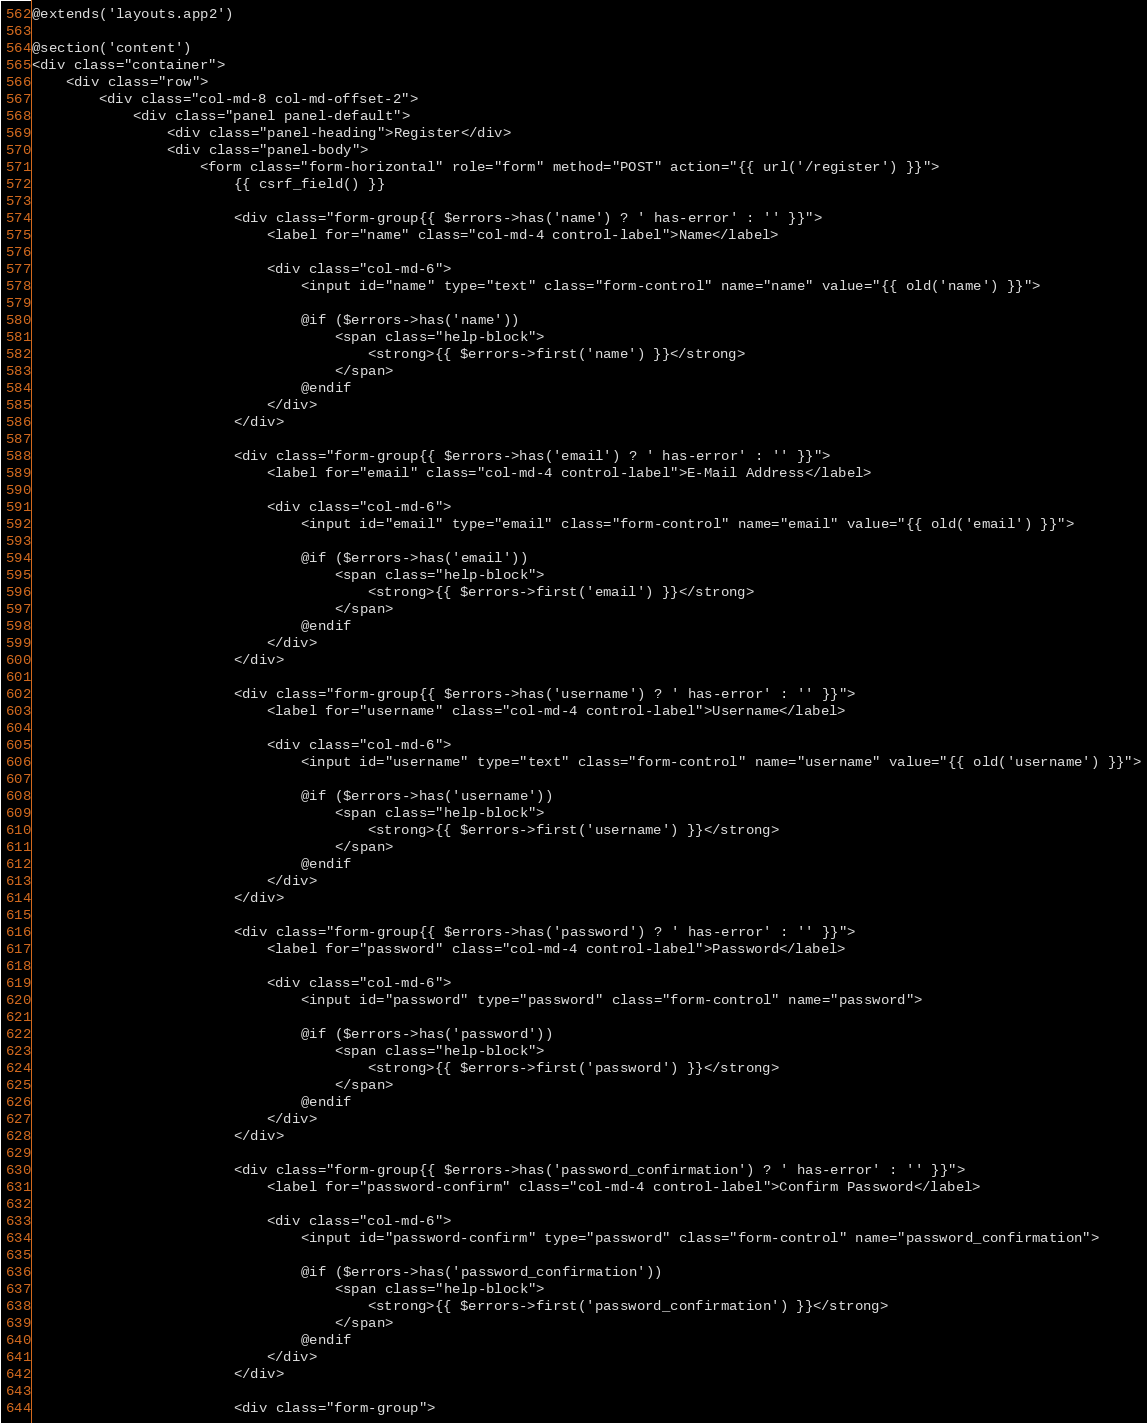Convert code to text. <code><loc_0><loc_0><loc_500><loc_500><_PHP_>@extends('layouts.app2')

@section('content')
<div class="container">
    <div class="row">
        <div class="col-md-8 col-md-offset-2">
            <div class="panel panel-default">
                <div class="panel-heading">Register</div>
                <div class="panel-body">
                    <form class="form-horizontal" role="form" method="POST" action="{{ url('/register') }}">
                        {{ csrf_field() }}

                        <div class="form-group{{ $errors->has('name') ? ' has-error' : '' }}">
                            <label for="name" class="col-md-4 control-label">Name</label>

                            <div class="col-md-6">
                                <input id="name" type="text" class="form-control" name="name" value="{{ old('name') }}">

                                @if ($errors->has('name'))
                                    <span class="help-block">
                                        <strong>{{ $errors->first('name') }}</strong>
                                    </span>
                                @endif
                            </div>
                        </div>

                        <div class="form-group{{ $errors->has('email') ? ' has-error' : '' }}">
                            <label for="email" class="col-md-4 control-label">E-Mail Address</label>

                            <div class="col-md-6">
                                <input id="email" type="email" class="form-control" name="email" value="{{ old('email') }}">

                                @if ($errors->has('email'))
                                    <span class="help-block">
                                        <strong>{{ $errors->first('email') }}</strong>
                                    </span>
                                @endif
                            </div>
                        </div>
                        
                        <div class="form-group{{ $errors->has('username') ? ' has-error' : '' }}">
                            <label for="username" class="col-md-4 control-label">Username</label>

                            <div class="col-md-6">
                                <input id="username" type="text" class="form-control" name="username" value="{{ old('username') }}">

                                @if ($errors->has('username'))
                                    <span class="help-block">
                                        <strong>{{ $errors->first('username') }}</strong>
                                    </span>
                                @endif
                            </div>
                        </div>

                        <div class="form-group{{ $errors->has('password') ? ' has-error' : '' }}">
                            <label for="password" class="col-md-4 control-label">Password</label>

                            <div class="col-md-6">
                                <input id="password" type="password" class="form-control" name="password">

                                @if ($errors->has('password'))
                                    <span class="help-block">
                                        <strong>{{ $errors->first('password') }}</strong>
                                    </span>
                                @endif
                            </div>
                        </div>

                        <div class="form-group{{ $errors->has('password_confirmation') ? ' has-error' : '' }}">
                            <label for="password-confirm" class="col-md-4 control-label">Confirm Password</label>

                            <div class="col-md-6">
                                <input id="password-confirm" type="password" class="form-control" name="password_confirmation">

                                @if ($errors->has('password_confirmation'))
                                    <span class="help-block">
                                        <strong>{{ $errors->first('password_confirmation') }}</strong>
                                    </span>
                                @endif
                            </div>
                        </div>

                        <div class="form-group"></code> 